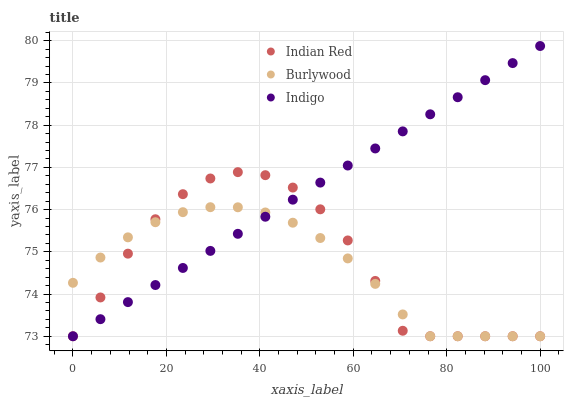Does Burlywood have the minimum area under the curve?
Answer yes or no. Yes. Does Indigo have the maximum area under the curve?
Answer yes or no. Yes. Does Indian Red have the minimum area under the curve?
Answer yes or no. No. Does Indian Red have the maximum area under the curve?
Answer yes or no. No. Is Indigo the smoothest?
Answer yes or no. Yes. Is Indian Red the roughest?
Answer yes or no. Yes. Is Indian Red the smoothest?
Answer yes or no. No. Is Indigo the roughest?
Answer yes or no. No. Does Burlywood have the lowest value?
Answer yes or no. Yes. Does Indigo have the highest value?
Answer yes or no. Yes. Does Indian Red have the highest value?
Answer yes or no. No. Does Indian Red intersect Indigo?
Answer yes or no. Yes. Is Indian Red less than Indigo?
Answer yes or no. No. Is Indian Red greater than Indigo?
Answer yes or no. No. 